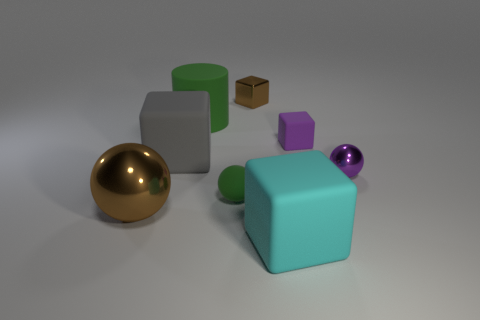There is another ball that is the same size as the purple metal ball; what is its color?
Provide a short and direct response. Green. What number of other objects are the same shape as the large cyan matte object?
Keep it short and to the point. 3. Is the size of the green sphere the same as the cyan matte thing?
Provide a short and direct response. No. Are there more rubber cylinders that are behind the small purple rubber cube than purple shiny objects that are left of the rubber ball?
Give a very brief answer. Yes. How many other objects are the same size as the green rubber sphere?
Provide a short and direct response. 3. Does the metal sphere behind the rubber sphere have the same color as the small rubber block?
Your response must be concise. Yes. Is the number of green balls to the left of the cyan object greater than the number of large blue objects?
Your answer should be very brief. Yes. Is there anything else of the same color as the large cylinder?
Your answer should be compact. Yes. What shape is the small matte thing that is to the left of the small block that is in front of the green rubber cylinder?
Offer a very short reply. Sphere. Is the number of small purple matte things greater than the number of small spheres?
Your response must be concise. No. 